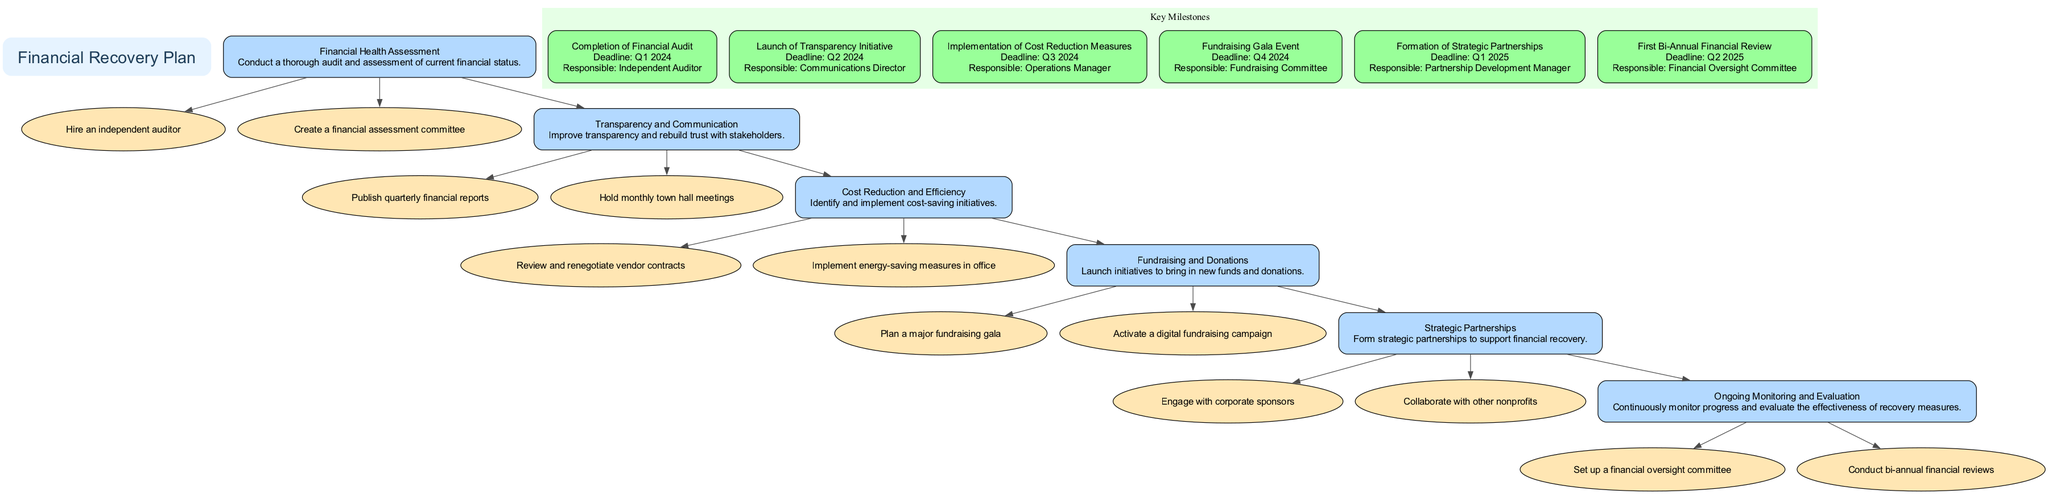What is the name of the first phase in the financial recovery plan? The first phase listed in the diagram is "Financial Health Assessment." This can be found as the first box under the main title of the diagram, representing the initial step of the recovery plan.
Answer: Financial Health Assessment How many accountability measures are associated with the "Cost Reduction and Efficiency" phase? The diagram shows two accountability measures connected to the "Cost Reduction and Efficiency" phase. They can be identified by counting the ellipses linked to this phase in the diagram.
Answer: 2 What is the deadline for the completion of the financial audit? According to the milestones listed in the diagram, the completion of the financial audit is due by "Q1 2024." This information is displayed as part of the milestone box.
Answer: Q1 2024 Who is responsible for publishing the public financial reports? The "Communications Director" is indicated as the responsible party for the launch of the transparency initiative, which includes publishing public financial reports. This information is listed under the corresponding milestone.
Answer: Communications Director Which phase directly precedes the "Fundraising and Donations" phase in the diagram? The "Cost Reduction and Efficiency" phase directly precedes the "Fundraising and Donations" phase in the flow of the diagram. This can be determined by following the arrows connecting these phases.
Answer: Cost Reduction and Efficiency What is the primary indicator for the implementation of cost reduction measures? The primary indicator for the implementation of cost reduction measures is "Cost Savings Realized on Balance Sheet," as stated directly under the cost reduction phase in the diagram.
Answer: Cost Savings Realized on Balance Sheet What type of measures will be published every quarter according to the transparency initiative? The measures that will be published quarterly are the "financial reports." This is outlined in the accountability measures linked to the transparency initiative phase of the diagram.
Answer: Financial reports How many key milestones are detailed in the diagram? The diagram illustrates a total of six key milestones, which can be counted in the "Key Milestones" cluster section of the diagram.
Answer: 6 What is the role of the "Operations Manager" in the recovery plan? The "Operations Manager" is responsible for the implementation of cost reduction measures, as indicated in the milestones within the diagram.
Answer: Implementation of cost reduction measures 